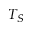<formula> <loc_0><loc_0><loc_500><loc_500>T _ { S }</formula> 